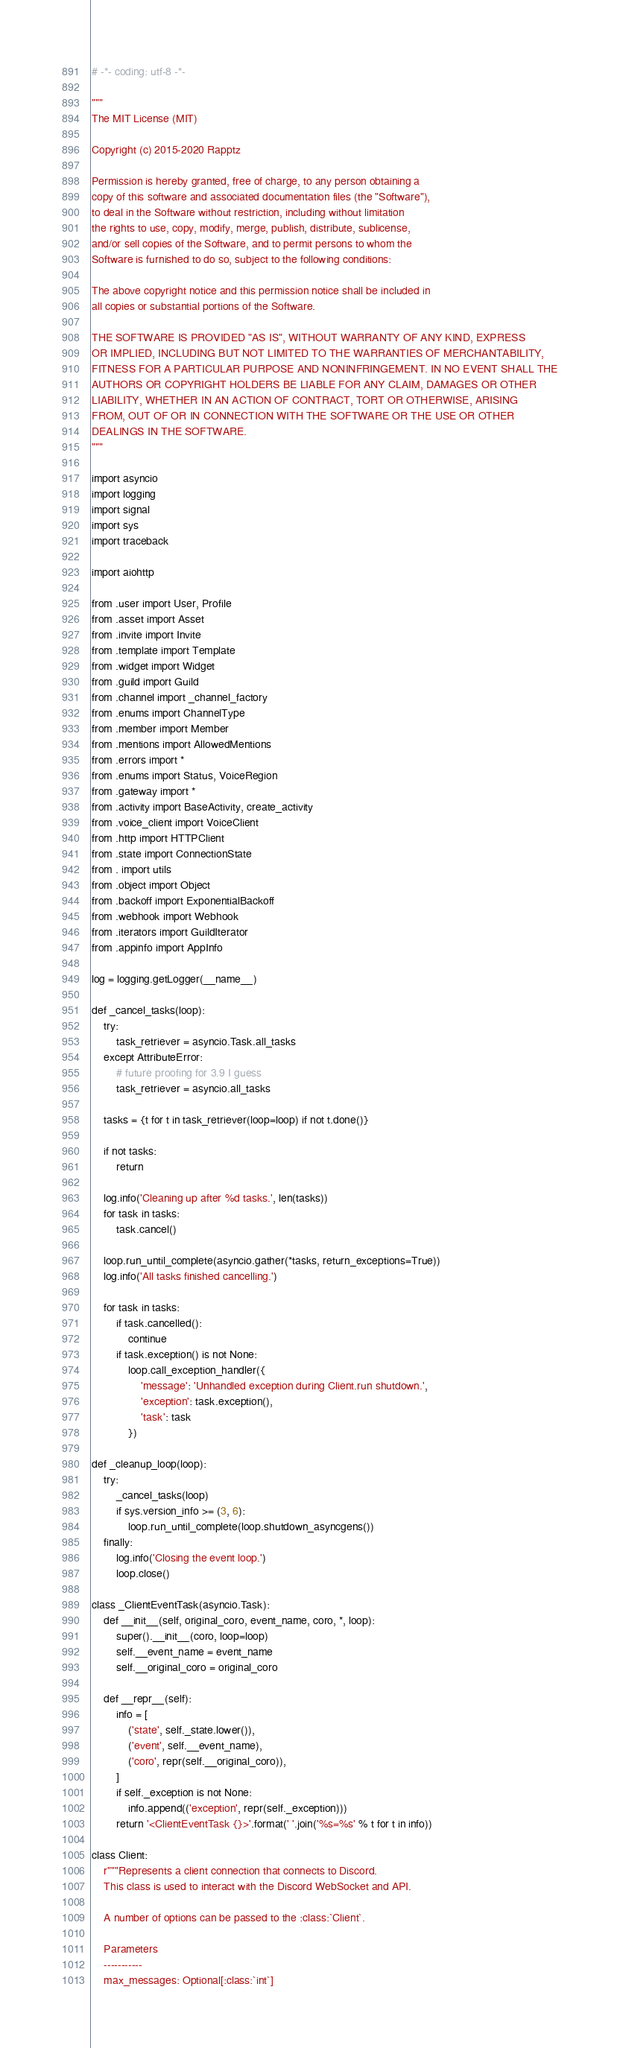Convert code to text. <code><loc_0><loc_0><loc_500><loc_500><_Python_># -*- coding: utf-8 -*-

"""
The MIT License (MIT)

Copyright (c) 2015-2020 Rapptz

Permission is hereby granted, free of charge, to any person obtaining a
copy of this software and associated documentation files (the "Software"),
to deal in the Software without restriction, including without limitation
the rights to use, copy, modify, merge, publish, distribute, sublicense,
and/or sell copies of the Software, and to permit persons to whom the
Software is furnished to do so, subject to the following conditions:

The above copyright notice and this permission notice shall be included in
all copies or substantial portions of the Software.

THE SOFTWARE IS PROVIDED "AS IS", WITHOUT WARRANTY OF ANY KIND, EXPRESS
OR IMPLIED, INCLUDING BUT NOT LIMITED TO THE WARRANTIES OF MERCHANTABILITY,
FITNESS FOR A PARTICULAR PURPOSE AND NONINFRINGEMENT. IN NO EVENT SHALL THE
AUTHORS OR COPYRIGHT HOLDERS BE LIABLE FOR ANY CLAIM, DAMAGES OR OTHER
LIABILITY, WHETHER IN AN ACTION OF CONTRACT, TORT OR OTHERWISE, ARISING
FROM, OUT OF OR IN CONNECTION WITH THE SOFTWARE OR THE USE OR OTHER
DEALINGS IN THE SOFTWARE.
"""

import asyncio
import logging
import signal
import sys
import traceback

import aiohttp

from .user import User, Profile
from .asset import Asset
from .invite import Invite
from .template import Template
from .widget import Widget
from .guild import Guild
from .channel import _channel_factory
from .enums import ChannelType
from .member import Member
from .mentions import AllowedMentions
from .errors import *
from .enums import Status, VoiceRegion
from .gateway import *
from .activity import BaseActivity, create_activity
from .voice_client import VoiceClient
from .http import HTTPClient
from .state import ConnectionState
from . import utils
from .object import Object
from .backoff import ExponentialBackoff
from .webhook import Webhook
from .iterators import GuildIterator
from .appinfo import AppInfo

log = logging.getLogger(__name__)

def _cancel_tasks(loop):
    try:
        task_retriever = asyncio.Task.all_tasks
    except AttributeError:
        # future proofing for 3.9 I guess
        task_retriever = asyncio.all_tasks

    tasks = {t for t in task_retriever(loop=loop) if not t.done()}

    if not tasks:
        return

    log.info('Cleaning up after %d tasks.', len(tasks))
    for task in tasks:
        task.cancel()

    loop.run_until_complete(asyncio.gather(*tasks, return_exceptions=True))
    log.info('All tasks finished cancelling.')

    for task in tasks:
        if task.cancelled():
            continue
        if task.exception() is not None:
            loop.call_exception_handler({
                'message': 'Unhandled exception during Client.run shutdown.',
                'exception': task.exception(),
                'task': task
            })

def _cleanup_loop(loop):
    try:
        _cancel_tasks(loop)
        if sys.version_info >= (3, 6):
            loop.run_until_complete(loop.shutdown_asyncgens())
    finally:
        log.info('Closing the event loop.')
        loop.close()

class _ClientEventTask(asyncio.Task):
    def __init__(self, original_coro, event_name, coro, *, loop):
        super().__init__(coro, loop=loop)
        self.__event_name = event_name
        self.__original_coro = original_coro

    def __repr__(self):
        info = [
            ('state', self._state.lower()),
            ('event', self.__event_name),
            ('coro', repr(self.__original_coro)),
        ]
        if self._exception is not None:
            info.append(('exception', repr(self._exception)))
        return '<ClientEventTask {}>'.format(' '.join('%s=%s' % t for t in info))

class Client:
    r"""Represents a client connection that connects to Discord.
    This class is used to interact with the Discord WebSocket and API.

    A number of options can be passed to the :class:`Client`.

    Parameters
    -----------
    max_messages: Optional[:class:`int`]</code> 